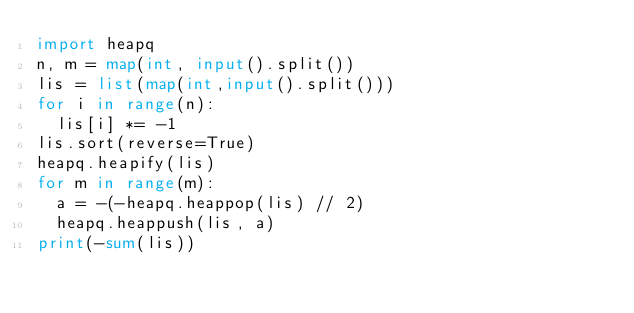<code> <loc_0><loc_0><loc_500><loc_500><_Python_>import heapq
n, m = map(int, input().split())
lis = list(map(int,input().split()))
for i in range(n):
  lis[i] *= -1
lis.sort(reverse=True)
heapq.heapify(lis)
for m in range(m):
  a = -(-heapq.heappop(lis) // 2)
  heapq.heappush(lis, a)
print(-sum(lis))</code> 